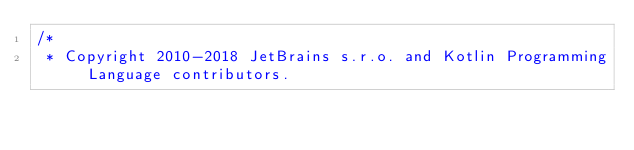<code> <loc_0><loc_0><loc_500><loc_500><_Kotlin_>/*
 * Copyright 2010-2018 JetBrains s.r.o. and Kotlin Programming Language contributors.</code> 